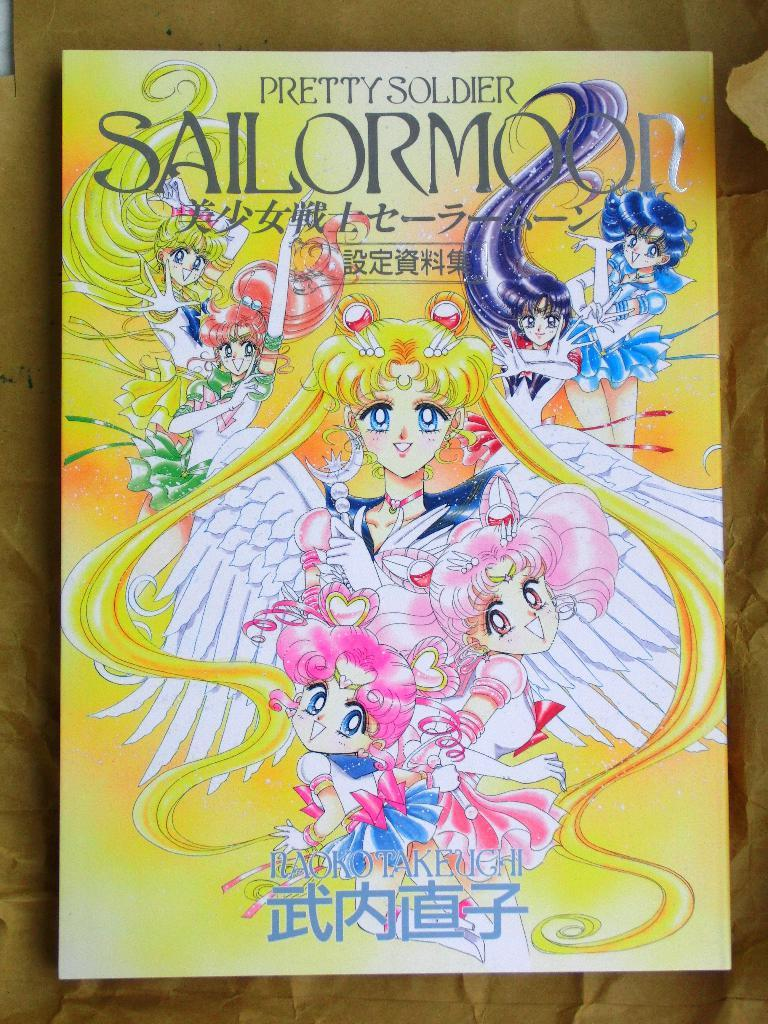What is present in the image that features a design or message? There is a poster in the image. Where is the poster located? The poster is on a surface. What type of images are depicted on the poster? The poster has animated pictures of women. Are there any words or phrases on the poster? Yes, there is text on the poster. Can you see any snow on the poster in the image? There is no snow present on the poster in the image. Is there a quiver visible on the poster in the image? There is no quiver depicted on the poster in the image. 